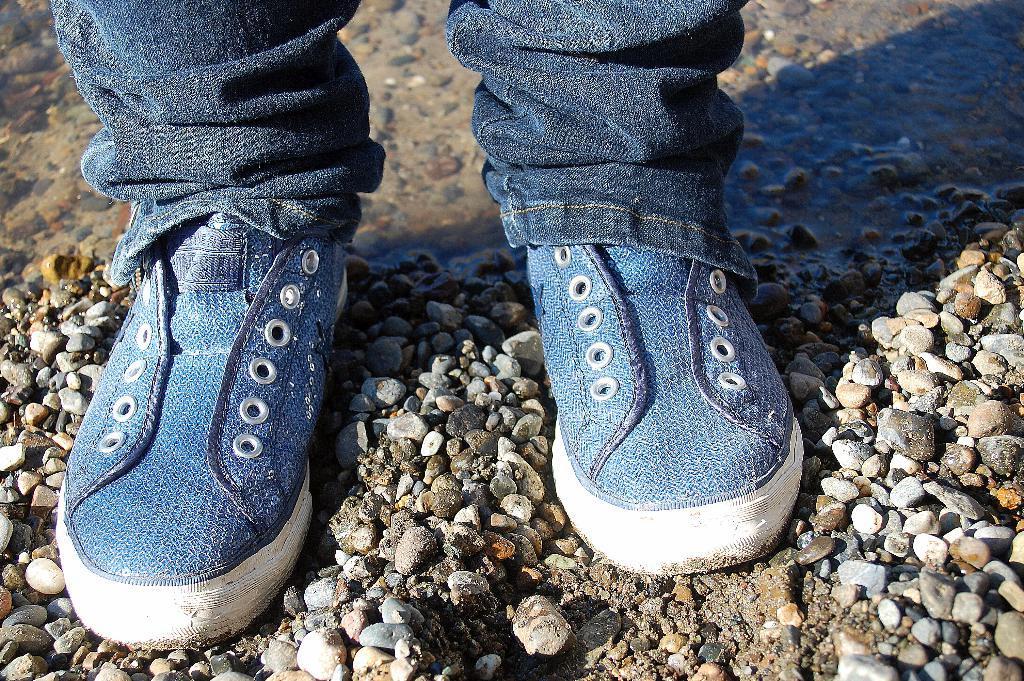Could you give a brief overview of what you see in this image? In this picture I can see human legs and I can see water, few stones on the ground and I can see blue color shoes. 